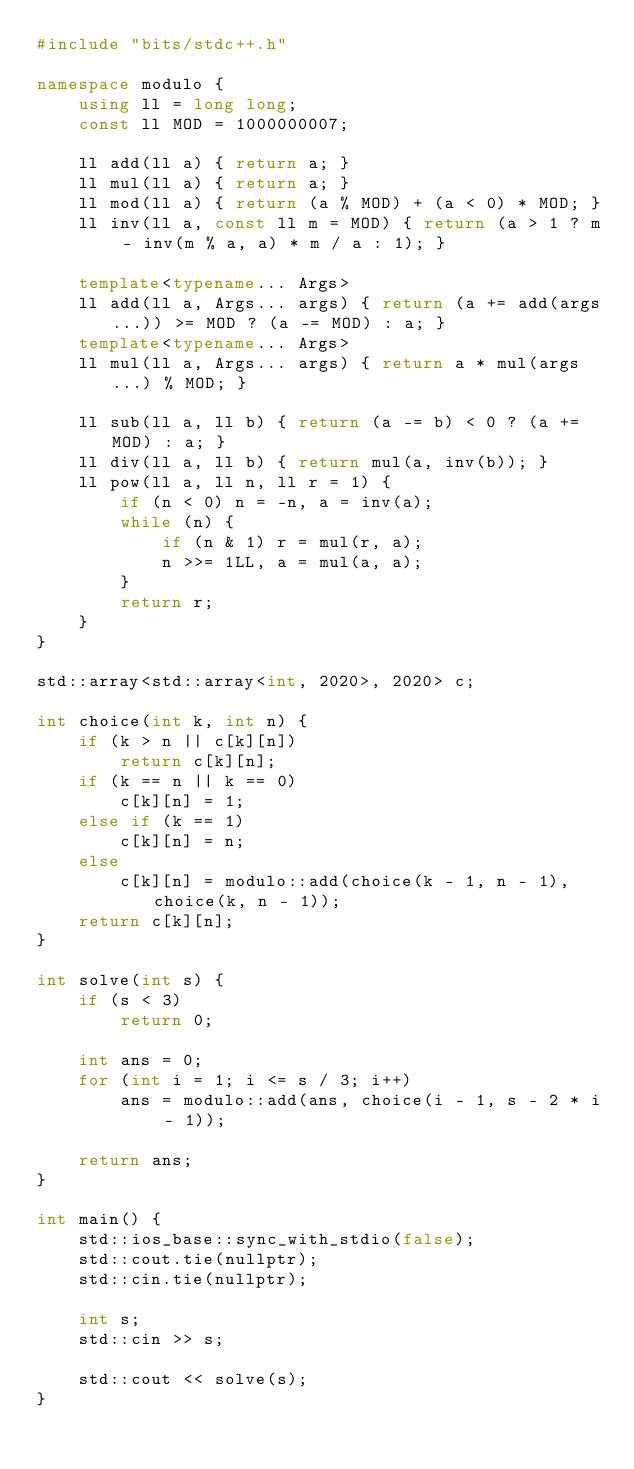Convert code to text. <code><loc_0><loc_0><loc_500><loc_500><_C++_>#include "bits/stdc++.h"

namespace modulo {
    using ll = long long;
    const ll MOD = 1000000007;
 
    ll add(ll a) { return a; }
    ll mul(ll a) { return a; }
    ll mod(ll a) { return (a % MOD) + (a < 0) * MOD; }
    ll inv(ll a, const ll m = MOD) { return (a > 1 ? m - inv(m % a, a) * m / a : 1); }
 
    template<typename... Args>
    ll add(ll a, Args... args) { return (a += add(args...)) >= MOD ? (a -= MOD) : a; }
    template<typename... Args>
    ll mul(ll a, Args... args) { return a * mul(args...) % MOD; }
 
    ll sub(ll a, ll b) { return (a -= b) < 0 ? (a += MOD) : a; }
    ll div(ll a, ll b) { return mul(a, inv(b)); }
    ll pow(ll a, ll n, ll r = 1) {
        if (n < 0) n = -n, a = inv(a);
        while (n) {
            if (n & 1) r = mul(r, a);
            n >>= 1LL, a = mul(a, a);
        }
        return r;
    }
}

std::array<std::array<int, 2020>, 2020> c;

int choice(int k, int n) {
    if (k > n || c[k][n])
        return c[k][n];
    if (k == n || k == 0)
        c[k][n] = 1;
    else if (k == 1)
        c[k][n] = n;
    else
        c[k][n] = modulo::add(choice(k - 1, n - 1), choice(k, n - 1));
    return c[k][n];
}

int solve(int s) {
    if (s < 3)
        return 0;

    int ans = 0;
    for (int i = 1; i <= s / 3; i++)
        ans = modulo::add(ans, choice(i - 1, s - 2 * i - 1));

    return ans;
}

int main() {
    std::ios_base::sync_with_stdio(false);
    std::cout.tie(nullptr);
    std::cin.tie(nullptr);

    int s;
    std::cin >> s;

    std::cout << solve(s);
}</code> 